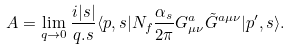<formula> <loc_0><loc_0><loc_500><loc_500>A = \lim _ { q \rightarrow 0 } \frac { i | s | } { q . s } \langle p , s | N _ { f } \frac { \alpha _ { s } } { 2 \pi } G _ { \mu \nu } ^ { a } \tilde { G } ^ { a \mu \nu } | p ^ { \prime } , s \rangle .</formula> 